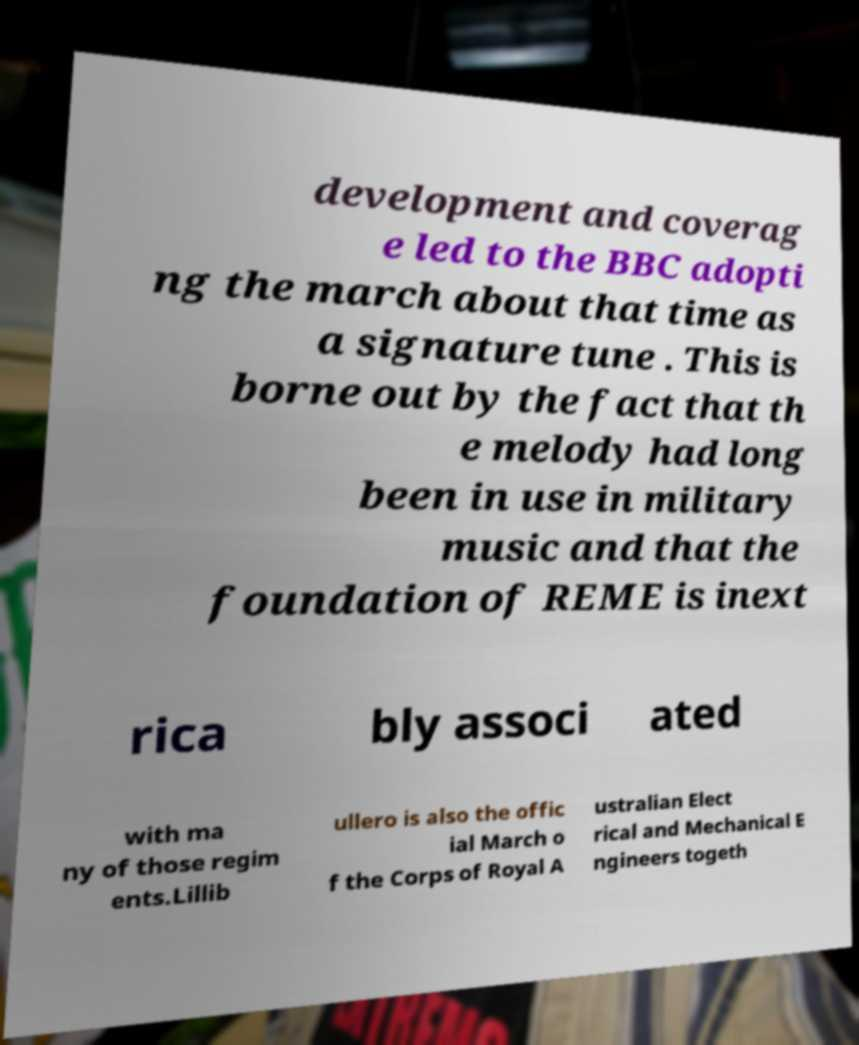Could you assist in decoding the text presented in this image and type it out clearly? development and coverag e led to the BBC adopti ng the march about that time as a signature tune . This is borne out by the fact that th e melody had long been in use in military music and that the foundation of REME is inext rica bly associ ated with ma ny of those regim ents.Lillib ullero is also the offic ial March o f the Corps of Royal A ustralian Elect rical and Mechanical E ngineers togeth 